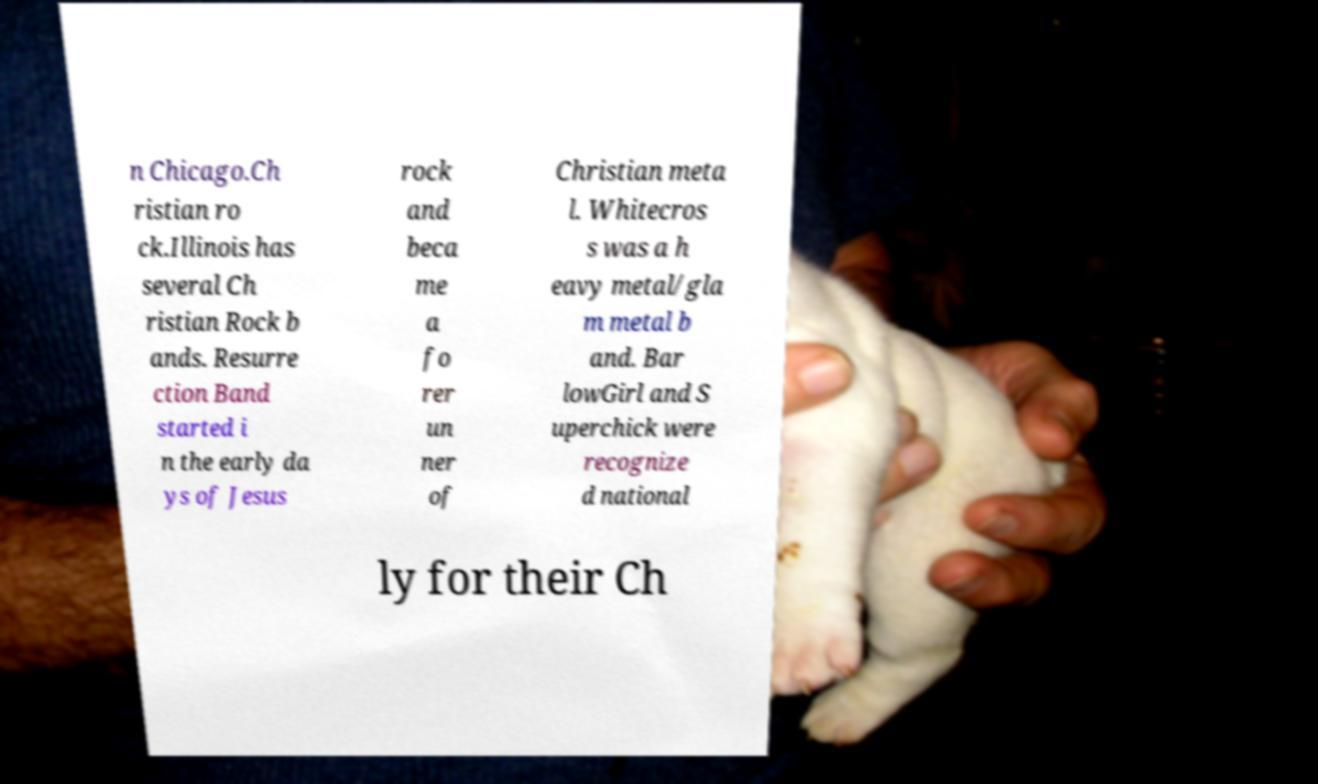What messages or text are displayed in this image? I need them in a readable, typed format. n Chicago.Ch ristian ro ck.Illinois has several Ch ristian Rock b ands. Resurre ction Band started i n the early da ys of Jesus rock and beca me a fo rer un ner of Christian meta l. Whitecros s was a h eavy metal/gla m metal b and. Bar lowGirl and S uperchick were recognize d national ly for their Ch 